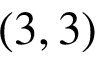Convert formula to latex. <formula><loc_0><loc_0><loc_500><loc_500>( 3 , 3 )</formula> 